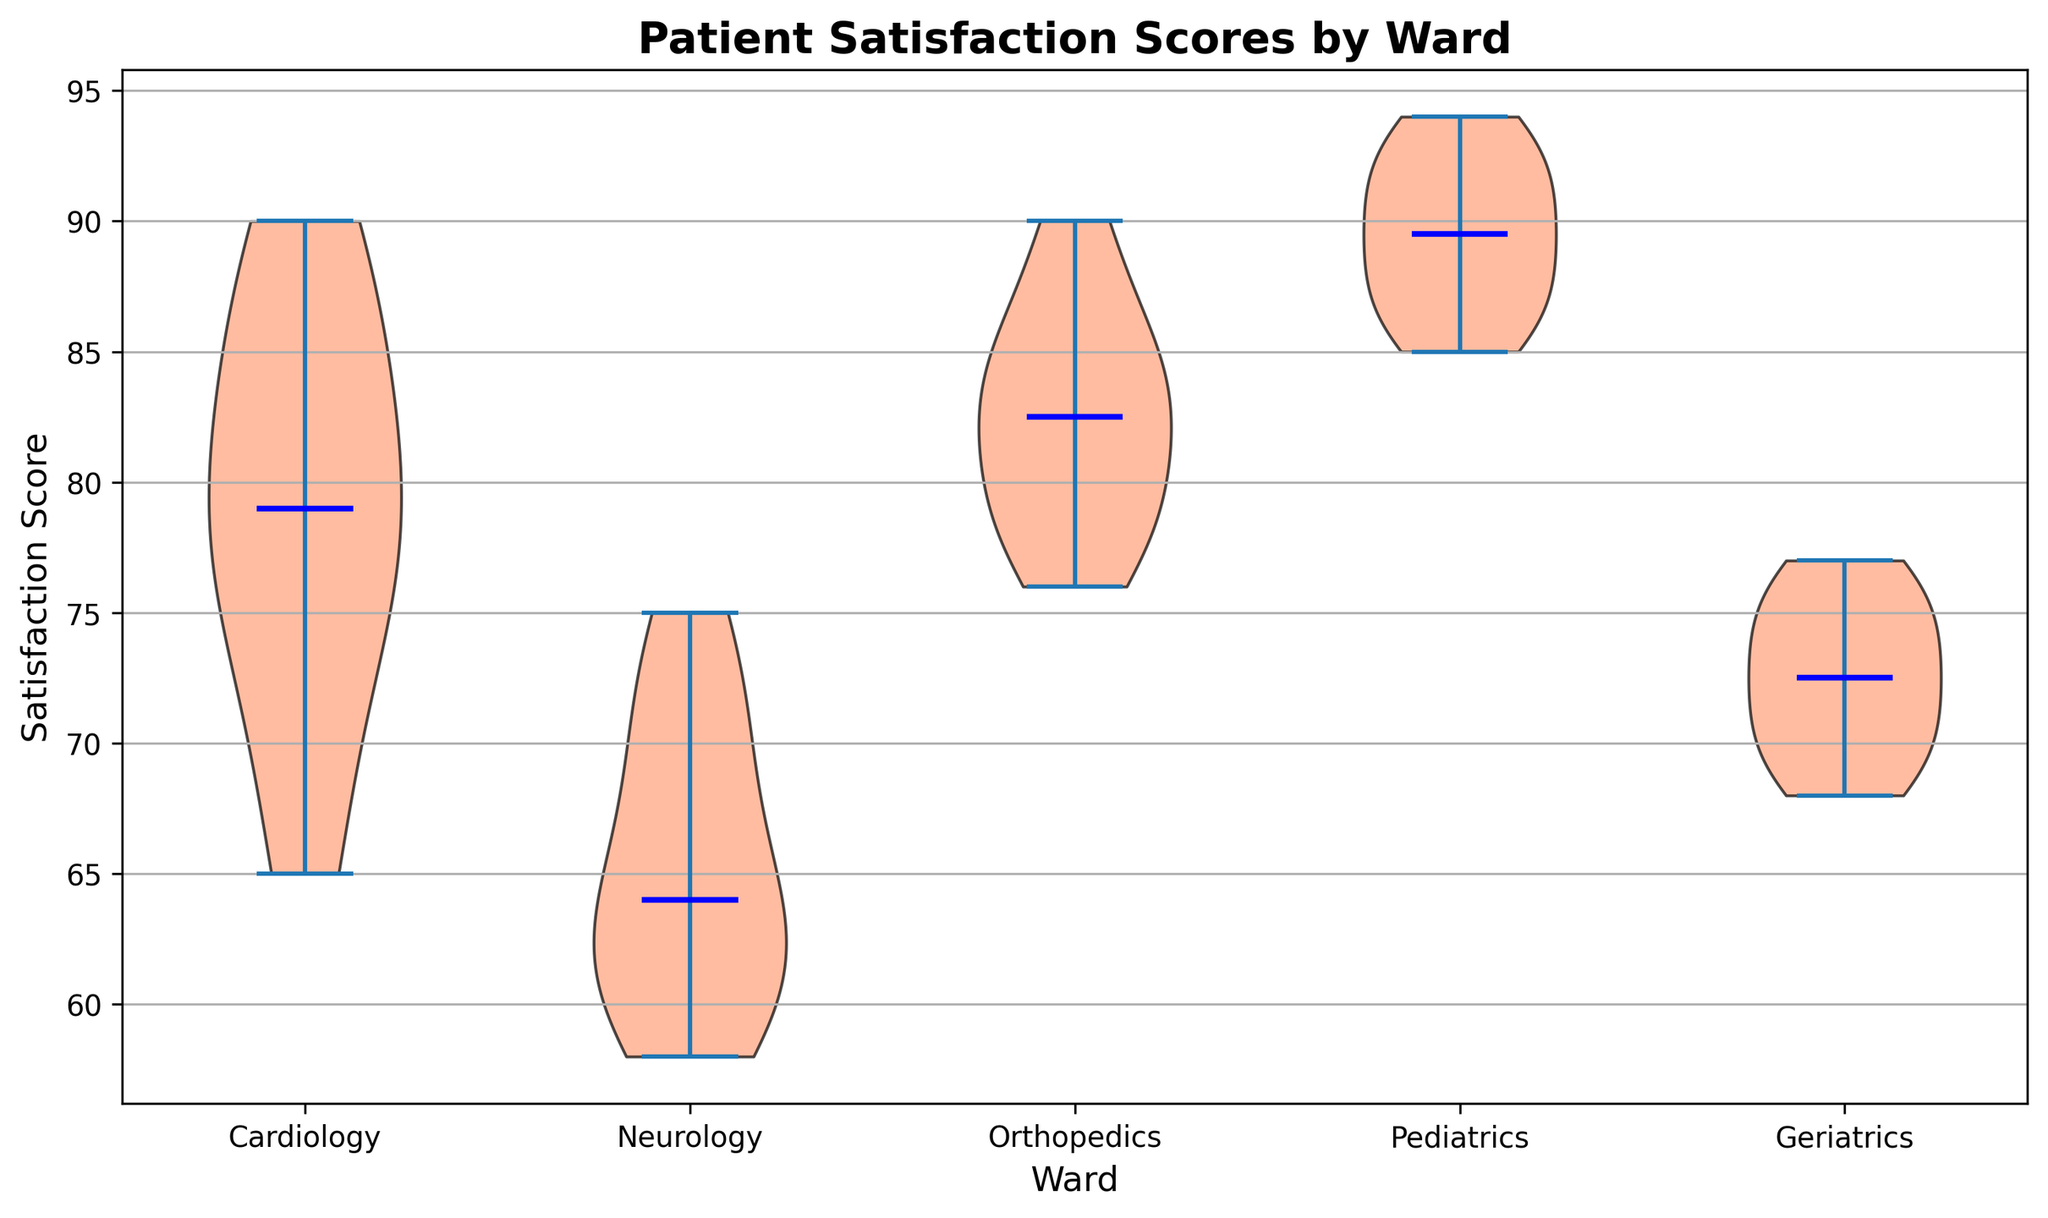What is the median satisfaction score for the Cardiology ward? The violin plot shows a vertical line indicating the median value for each ward. For the Cardiology ward, this line represents the median satisfaction score.
Answer: 78 How does the median satisfaction score of the Neurology ward compare to that of the Cardiology ward? Observe the median lines for both wards. The median satisfaction score of the Neurology ward is visually lower than that of the Cardiology ward.
Answer: Lower Which ward has the highest median satisfaction score? The ward with the highest median satisfaction score will have the highest vertical line among the medians shown in the violin plot.
Answer: Pediatrics Compare the distribution spread of satisfaction scores between Orthopedics and Geriatrics. The spread (width of the shape) of the satisfaction scores distribution in Orthopedics is wider than that of Geriatrics, indicating greater variability in Orthopedics.
Answer: Orthopedics has a wider spread Is the median satisfaction score for Pediatrics closer to the upper end or lower end of its distribution? The median (vertical line) is placed closer to the lower part of the distribution for Pediatrics, indicating it is closer to the lower end.
Answer: Lower end What is the range of satisfaction scores for the Geriatrics ward? From the violin plot, the range of satisfaction scores for Geriatrics can be estimated by looking at the upper and lower extremes of the shape.
Answer: 68 to 77 Compare the satisfaction score distribution shapes between Cardiology and Neurology. The Neurology ward shows a more concentrated and narrower distribution compared to Cardiology, which is more spread out.
Answer: Neurology is more concentrated Which ward exhibits the least variability in satisfaction scores? The least variability is indicated by the narrowest part of the distribution shape in the violin plot.
Answer: Neurology How does the overall satisfaction score trend differ between Geriatrics and Pediatrics? Geriatrics shows a consistent distribution with a gradual slope, while Pediatrics has a steep distribution trend with scores clustered toward higher values.
Answer: Pediatrics scores higher overall 